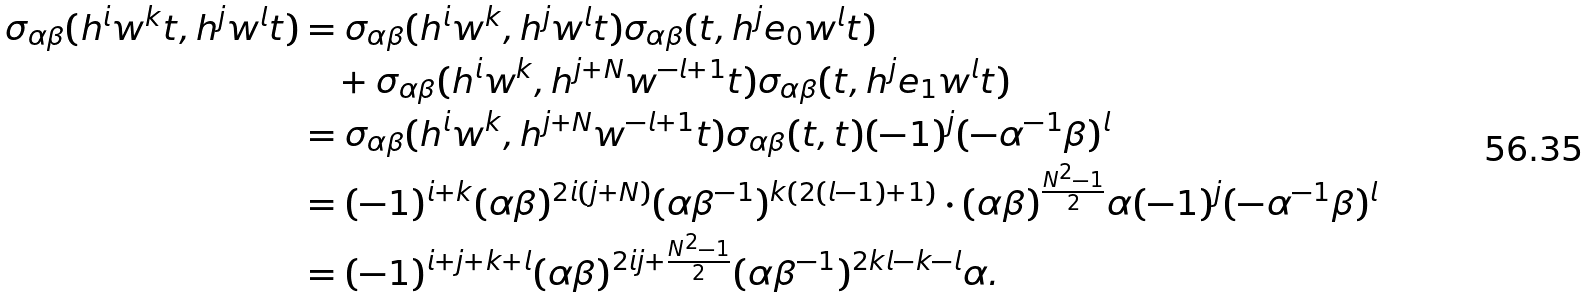Convert formula to latex. <formula><loc_0><loc_0><loc_500><loc_500>\sigma _ { \alpha \beta } ( h ^ { i } w ^ { k } t , h ^ { j } w ^ { l } t ) & = \sigma _ { \alpha \beta } ( h ^ { i } w ^ { k } , h ^ { j } w ^ { l } t ) \sigma _ { \alpha \beta } ( t , h ^ { j } e _ { 0 } w ^ { l } t ) \\ & \quad + \sigma _ { \alpha \beta } ( h ^ { i } w ^ { k } , h ^ { j + N } w ^ { - l + 1 } t ) \sigma _ { \alpha \beta } ( t , h ^ { j } e _ { 1 } w ^ { l } t ) \\ & = \sigma _ { \alpha \beta } ( h ^ { i } w ^ { k } , h ^ { j + N } w ^ { - l + 1 } t ) \sigma _ { \alpha \beta } ( t , t ) ( - 1 ) ^ { j } ( - \alpha ^ { - 1 } \beta ) ^ { l } \\ & = ( - 1 ) ^ { i + k } ( \alpha \beta ) ^ { 2 i ( j + N ) } ( \alpha \beta ^ { - 1 } ) ^ { k ( 2 ( l - 1 ) + 1 ) } \cdot ( \alpha \beta ) ^ { \frac { N ^ { 2 } - 1 } { 2 } } \alpha ( - 1 ) ^ { j } ( - \alpha ^ { - 1 } \beta ) ^ { l } \\ & = ( - 1 ) ^ { i + j + k + l } ( \alpha \beta ) ^ { 2 i j + \frac { N ^ { 2 } - 1 } { 2 } } ( \alpha \beta ^ { - 1 } ) ^ { 2 k l - k - l } \alpha .</formula> 